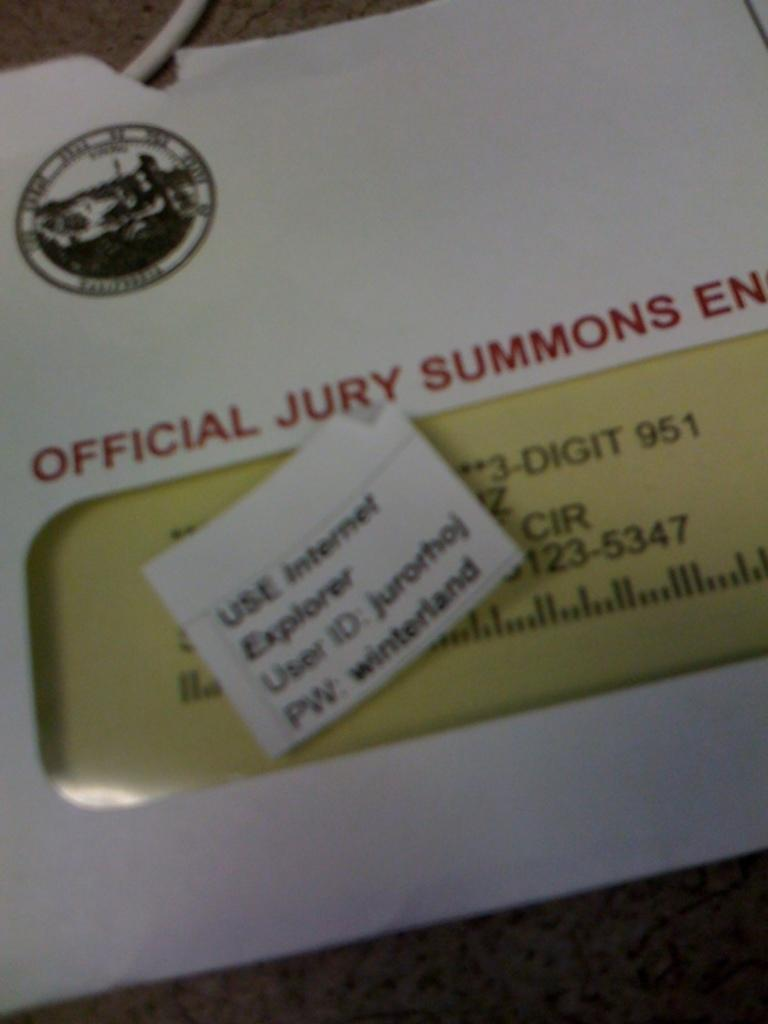<image>
Present a compact description of the photo's key features. An envelope that says official jury summons enclosed 